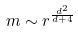Convert formula to latex. <formula><loc_0><loc_0><loc_500><loc_500>m \sim r ^ { \frac { d ^ { 2 } } { d + 4 } }</formula> 